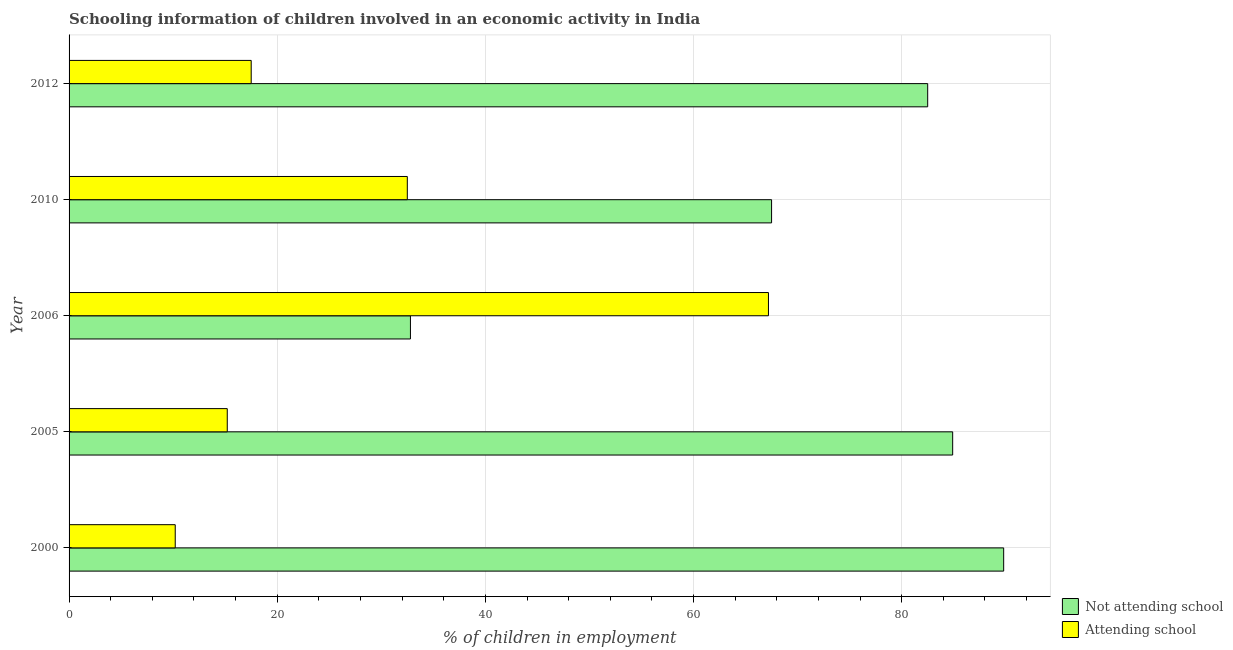How many groups of bars are there?
Offer a very short reply. 5. Are the number of bars per tick equal to the number of legend labels?
Make the answer very short. Yes. What is the label of the 2nd group of bars from the top?
Provide a succinct answer. 2010. What is the percentage of employed children who are not attending school in 2006?
Give a very brief answer. 32.8. Across all years, what is the maximum percentage of employed children who are not attending school?
Provide a succinct answer. 89.8. Across all years, what is the minimum percentage of employed children who are not attending school?
Give a very brief answer. 32.8. In which year was the percentage of employed children who are not attending school minimum?
Provide a short and direct response. 2006. What is the total percentage of employed children who are not attending school in the graph?
Your response must be concise. 357.5. What is the difference between the percentage of employed children who are not attending school in 2006 and that in 2012?
Make the answer very short. -49.7. What is the difference between the percentage of employed children who are attending school in 2006 and the percentage of employed children who are not attending school in 2012?
Offer a very short reply. -15.3. What is the average percentage of employed children who are attending school per year?
Your answer should be compact. 28.52. In the year 2006, what is the difference between the percentage of employed children who are not attending school and percentage of employed children who are attending school?
Offer a very short reply. -34.4. What is the ratio of the percentage of employed children who are not attending school in 2000 to that in 2006?
Provide a succinct answer. 2.74. Is the difference between the percentage of employed children who are attending school in 2000 and 2006 greater than the difference between the percentage of employed children who are not attending school in 2000 and 2006?
Your answer should be compact. No. What is the difference between the highest and the second highest percentage of employed children who are attending school?
Your answer should be compact. 34.7. What is the difference between the highest and the lowest percentage of employed children who are attending school?
Offer a terse response. 57. What does the 1st bar from the top in 2005 represents?
Ensure brevity in your answer.  Attending school. What does the 1st bar from the bottom in 2005 represents?
Provide a short and direct response. Not attending school. How many years are there in the graph?
Ensure brevity in your answer.  5. What is the difference between two consecutive major ticks on the X-axis?
Give a very brief answer. 20. Are the values on the major ticks of X-axis written in scientific E-notation?
Provide a succinct answer. No. Does the graph contain any zero values?
Your answer should be compact. No. Does the graph contain grids?
Ensure brevity in your answer.  Yes. Where does the legend appear in the graph?
Keep it short and to the point. Bottom right. How many legend labels are there?
Provide a succinct answer. 2. What is the title of the graph?
Your answer should be very brief. Schooling information of children involved in an economic activity in India. Does "% of gross capital formation" appear as one of the legend labels in the graph?
Provide a succinct answer. No. What is the label or title of the X-axis?
Offer a terse response. % of children in employment. What is the % of children in employment of Not attending school in 2000?
Provide a short and direct response. 89.8. What is the % of children in employment of Not attending school in 2005?
Your answer should be very brief. 84.9. What is the % of children in employment of Not attending school in 2006?
Provide a succinct answer. 32.8. What is the % of children in employment of Attending school in 2006?
Provide a succinct answer. 67.2. What is the % of children in employment in Not attending school in 2010?
Offer a terse response. 67.5. What is the % of children in employment of Attending school in 2010?
Your answer should be compact. 32.5. What is the % of children in employment of Not attending school in 2012?
Ensure brevity in your answer.  82.5. Across all years, what is the maximum % of children in employment in Not attending school?
Keep it short and to the point. 89.8. Across all years, what is the maximum % of children in employment of Attending school?
Provide a short and direct response. 67.2. Across all years, what is the minimum % of children in employment in Not attending school?
Make the answer very short. 32.8. Across all years, what is the minimum % of children in employment of Attending school?
Make the answer very short. 10.2. What is the total % of children in employment of Not attending school in the graph?
Offer a very short reply. 357.5. What is the total % of children in employment in Attending school in the graph?
Keep it short and to the point. 142.6. What is the difference between the % of children in employment of Attending school in 2000 and that in 2006?
Your answer should be compact. -57. What is the difference between the % of children in employment in Not attending school in 2000 and that in 2010?
Provide a succinct answer. 22.3. What is the difference between the % of children in employment in Attending school in 2000 and that in 2010?
Give a very brief answer. -22.3. What is the difference between the % of children in employment in Attending school in 2000 and that in 2012?
Provide a short and direct response. -7.3. What is the difference between the % of children in employment of Not attending school in 2005 and that in 2006?
Your answer should be very brief. 52.1. What is the difference between the % of children in employment in Attending school in 2005 and that in 2006?
Ensure brevity in your answer.  -52. What is the difference between the % of children in employment of Attending school in 2005 and that in 2010?
Your answer should be very brief. -17.3. What is the difference between the % of children in employment of Not attending school in 2006 and that in 2010?
Your response must be concise. -34.7. What is the difference between the % of children in employment in Attending school in 2006 and that in 2010?
Provide a succinct answer. 34.7. What is the difference between the % of children in employment of Not attending school in 2006 and that in 2012?
Offer a terse response. -49.7. What is the difference between the % of children in employment in Attending school in 2006 and that in 2012?
Make the answer very short. 49.7. What is the difference between the % of children in employment in Not attending school in 2010 and that in 2012?
Provide a succinct answer. -15. What is the difference between the % of children in employment of Not attending school in 2000 and the % of children in employment of Attending school in 2005?
Ensure brevity in your answer.  74.6. What is the difference between the % of children in employment in Not attending school in 2000 and the % of children in employment in Attending school in 2006?
Your answer should be compact. 22.6. What is the difference between the % of children in employment in Not attending school in 2000 and the % of children in employment in Attending school in 2010?
Your answer should be compact. 57.3. What is the difference between the % of children in employment in Not attending school in 2000 and the % of children in employment in Attending school in 2012?
Make the answer very short. 72.3. What is the difference between the % of children in employment in Not attending school in 2005 and the % of children in employment in Attending school in 2010?
Keep it short and to the point. 52.4. What is the difference between the % of children in employment in Not attending school in 2005 and the % of children in employment in Attending school in 2012?
Provide a succinct answer. 67.4. What is the difference between the % of children in employment of Not attending school in 2006 and the % of children in employment of Attending school in 2010?
Your response must be concise. 0.3. What is the difference between the % of children in employment of Not attending school in 2006 and the % of children in employment of Attending school in 2012?
Give a very brief answer. 15.3. What is the average % of children in employment in Not attending school per year?
Your response must be concise. 71.5. What is the average % of children in employment of Attending school per year?
Give a very brief answer. 28.52. In the year 2000, what is the difference between the % of children in employment of Not attending school and % of children in employment of Attending school?
Your response must be concise. 79.6. In the year 2005, what is the difference between the % of children in employment of Not attending school and % of children in employment of Attending school?
Give a very brief answer. 69.7. In the year 2006, what is the difference between the % of children in employment of Not attending school and % of children in employment of Attending school?
Your answer should be very brief. -34.4. In the year 2010, what is the difference between the % of children in employment in Not attending school and % of children in employment in Attending school?
Keep it short and to the point. 35. What is the ratio of the % of children in employment in Not attending school in 2000 to that in 2005?
Provide a succinct answer. 1.06. What is the ratio of the % of children in employment in Attending school in 2000 to that in 2005?
Offer a terse response. 0.67. What is the ratio of the % of children in employment of Not attending school in 2000 to that in 2006?
Ensure brevity in your answer.  2.74. What is the ratio of the % of children in employment of Attending school in 2000 to that in 2006?
Offer a terse response. 0.15. What is the ratio of the % of children in employment of Not attending school in 2000 to that in 2010?
Your response must be concise. 1.33. What is the ratio of the % of children in employment in Attending school in 2000 to that in 2010?
Give a very brief answer. 0.31. What is the ratio of the % of children in employment of Not attending school in 2000 to that in 2012?
Ensure brevity in your answer.  1.09. What is the ratio of the % of children in employment of Attending school in 2000 to that in 2012?
Provide a short and direct response. 0.58. What is the ratio of the % of children in employment of Not attending school in 2005 to that in 2006?
Keep it short and to the point. 2.59. What is the ratio of the % of children in employment in Attending school in 2005 to that in 2006?
Ensure brevity in your answer.  0.23. What is the ratio of the % of children in employment in Not attending school in 2005 to that in 2010?
Ensure brevity in your answer.  1.26. What is the ratio of the % of children in employment in Attending school in 2005 to that in 2010?
Make the answer very short. 0.47. What is the ratio of the % of children in employment of Not attending school in 2005 to that in 2012?
Your answer should be very brief. 1.03. What is the ratio of the % of children in employment of Attending school in 2005 to that in 2012?
Make the answer very short. 0.87. What is the ratio of the % of children in employment in Not attending school in 2006 to that in 2010?
Your response must be concise. 0.49. What is the ratio of the % of children in employment of Attending school in 2006 to that in 2010?
Provide a short and direct response. 2.07. What is the ratio of the % of children in employment of Not attending school in 2006 to that in 2012?
Give a very brief answer. 0.4. What is the ratio of the % of children in employment in Attending school in 2006 to that in 2012?
Offer a very short reply. 3.84. What is the ratio of the % of children in employment in Not attending school in 2010 to that in 2012?
Ensure brevity in your answer.  0.82. What is the ratio of the % of children in employment in Attending school in 2010 to that in 2012?
Your response must be concise. 1.86. What is the difference between the highest and the second highest % of children in employment of Attending school?
Your answer should be very brief. 34.7. What is the difference between the highest and the lowest % of children in employment of Not attending school?
Offer a very short reply. 57. 